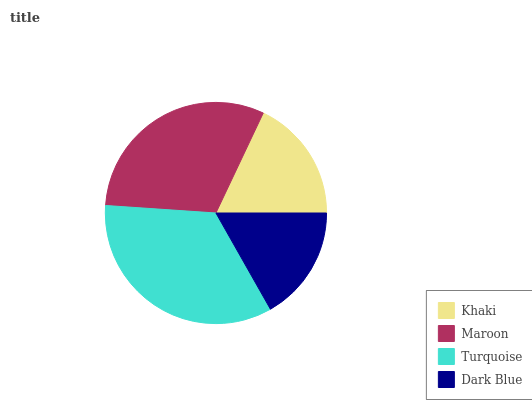Is Dark Blue the minimum?
Answer yes or no. Yes. Is Turquoise the maximum?
Answer yes or no. Yes. Is Maroon the minimum?
Answer yes or no. No. Is Maroon the maximum?
Answer yes or no. No. Is Maroon greater than Khaki?
Answer yes or no. Yes. Is Khaki less than Maroon?
Answer yes or no. Yes. Is Khaki greater than Maroon?
Answer yes or no. No. Is Maroon less than Khaki?
Answer yes or no. No. Is Maroon the high median?
Answer yes or no. Yes. Is Khaki the low median?
Answer yes or no. Yes. Is Dark Blue the high median?
Answer yes or no. No. Is Turquoise the low median?
Answer yes or no. No. 